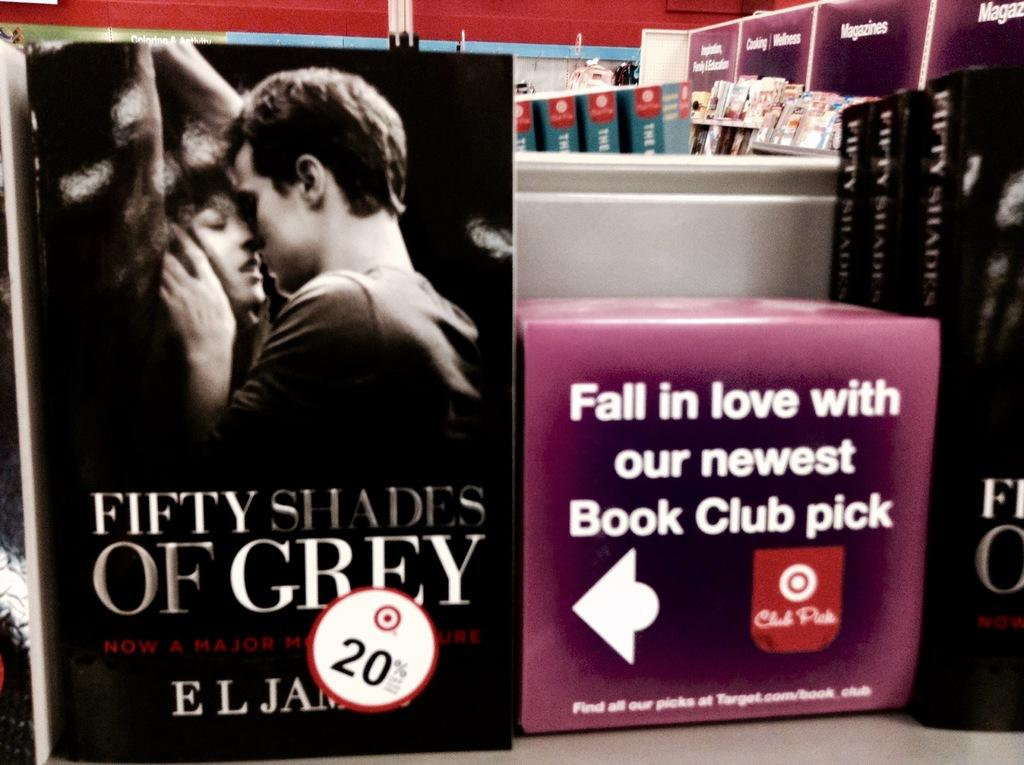<image>
Create a compact narrative representing the image presented. A romance novel that is part of a book club. 